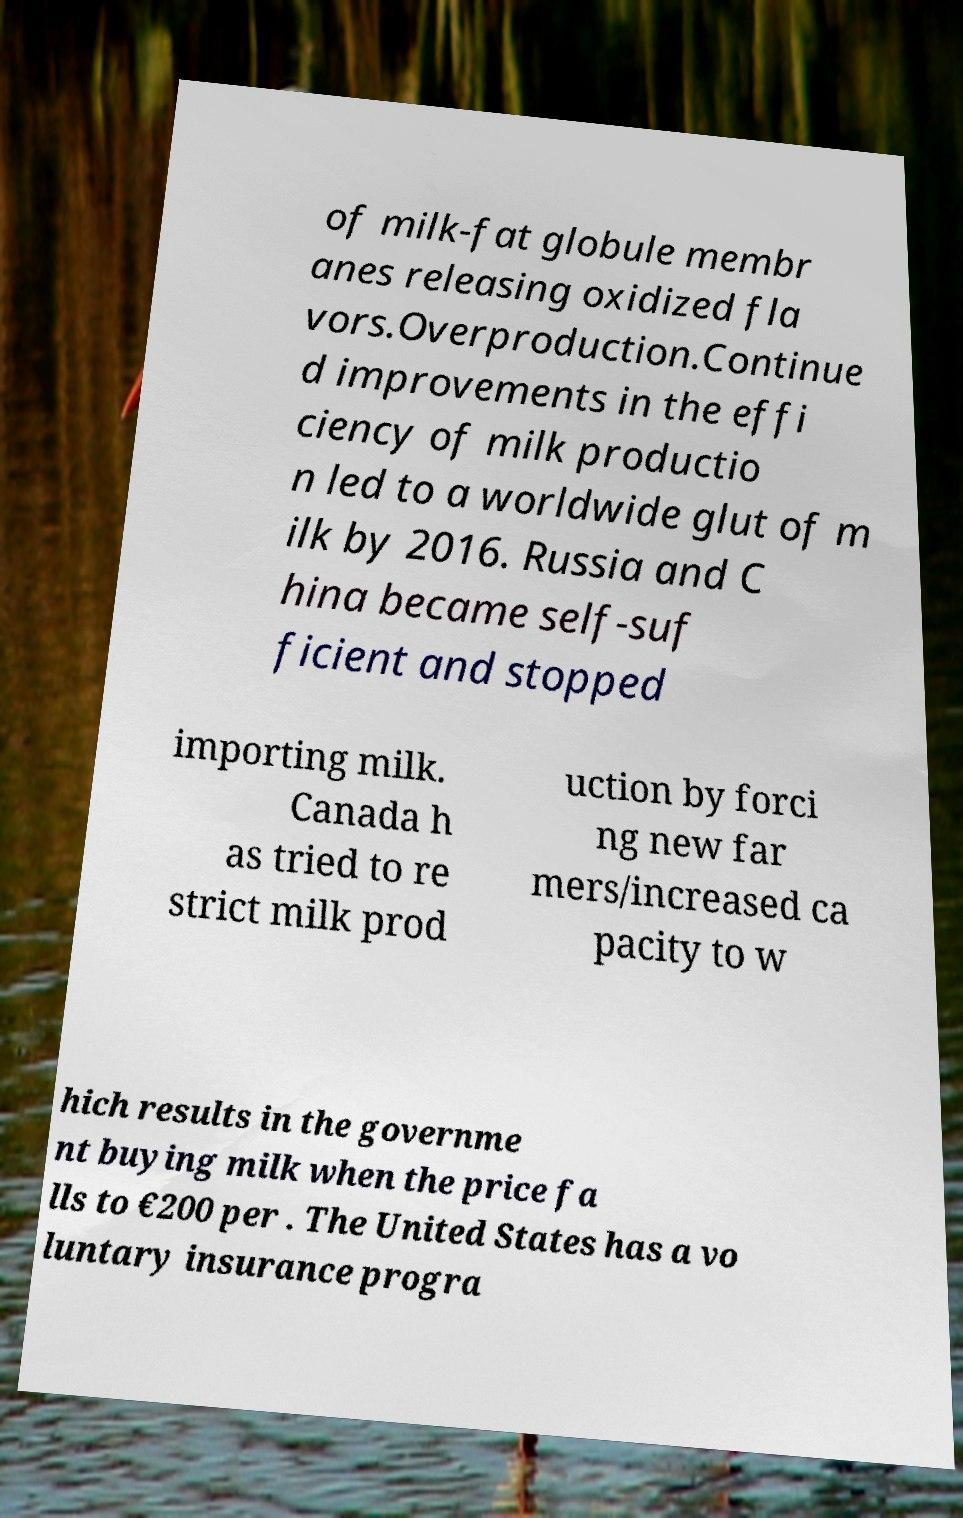Can you read and provide the text displayed in the image?This photo seems to have some interesting text. Can you extract and type it out for me? of milk-fat globule membr anes releasing oxidized fla vors.Overproduction.Continue d improvements in the effi ciency of milk productio n led to a worldwide glut of m ilk by 2016. Russia and C hina became self-suf ficient and stopped importing milk. Canada h as tried to re strict milk prod uction by forci ng new far mers/increased ca pacity to w hich results in the governme nt buying milk when the price fa lls to €200 per . The United States has a vo luntary insurance progra 